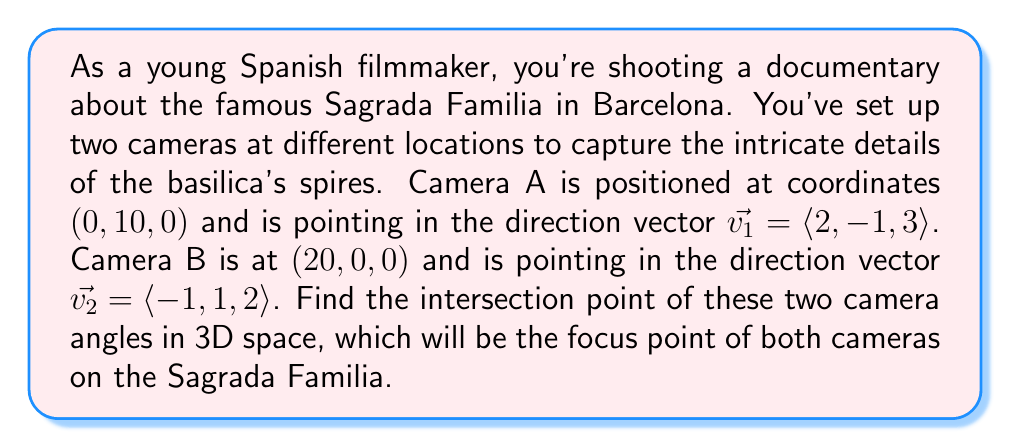What is the answer to this math problem? To solve this problem, we need to use the concept of parametric equations for lines in 3D space and find their intersection point. Let's approach this step-by-step:

1) First, we need to write the parametric equations for each camera's line of sight:

   For Camera A: $$(x, y, z) = (0, 10, 0) + t\langle 2, -1, 3 \rangle$$
   For Camera B: $$(x, y, z) = (20, 0, 0) + s\langle -1, 1, 2 \rangle$$

2) Expanding these equations:

   Camera A: 
   $$x = 0 + 2t$$
   $$y = 10 - t$$
   $$z = 0 + 3t$$

   Camera B:
   $$x = 20 - s$$
   $$y = 0 + s$$
   $$z = 0 + 2s$$

3) For these lines to intersect, their x, y, and z coordinates must be equal. So we can set up a system of equations:

   $$2t = 20 - s$$
   $$10 - t = s$$
   $$3t = 2s$$

4) From the second equation, we can express s in terms of t:
   $$s = 10 - t$$

5) Substituting this into the first equation:
   $$2t = 20 - (10 - t)$$
   $$2t = 10 + t$$
   $$t = 10$$

6) Now we can find s:
   $$s = 10 - t = 10 - 10 = 0$$

7) We can verify this solution using the third equation:
   $$3t = 2s$$
   $$3(10) = 2(0)$$
   $$30 = 0$$ (This is true)

8) Now that we have t and s, we can substitute these values into either of our original parametric equations to find the intersection point. Let's use Camera A's equation:

   $$(x, y, z) = (0, 10, 0) + 10\langle 2, -1, 3 \rangle$$
   $$(x, y, z) = (0, 10, 0) + (20, -10, 30)$$
   $$(x, y, z) = (20, 0, 30)$$

Therefore, the intersection point of the two camera angles is at (20, 0, 30).
Answer: The intersection point of the two camera angles is (20, 0, 30). 